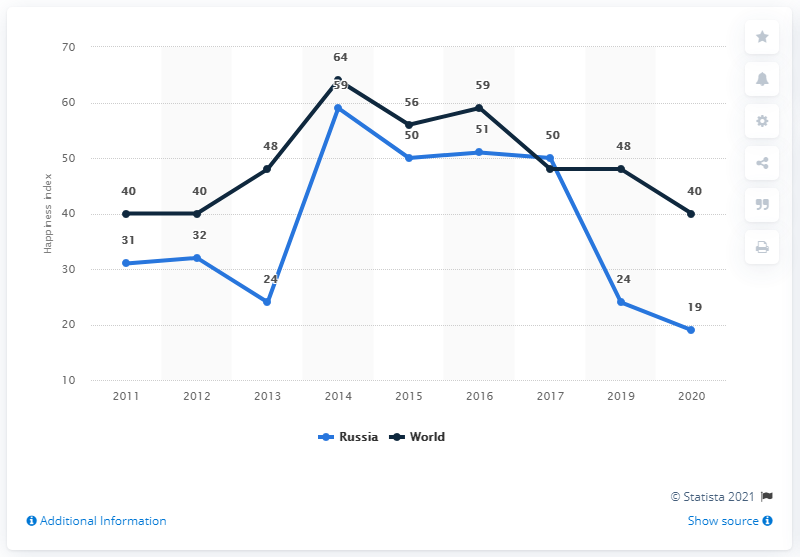Specify some key components in this picture. In the year that the happiness index reached the level it was at in 2013. 